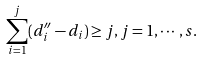Convert formula to latex. <formula><loc_0><loc_0><loc_500><loc_500>\sum _ { i = 1 } ^ { j } ( d ^ { \prime \prime } _ { i } - d _ { i } ) \geq j , j = 1 , \cdots , s .</formula> 